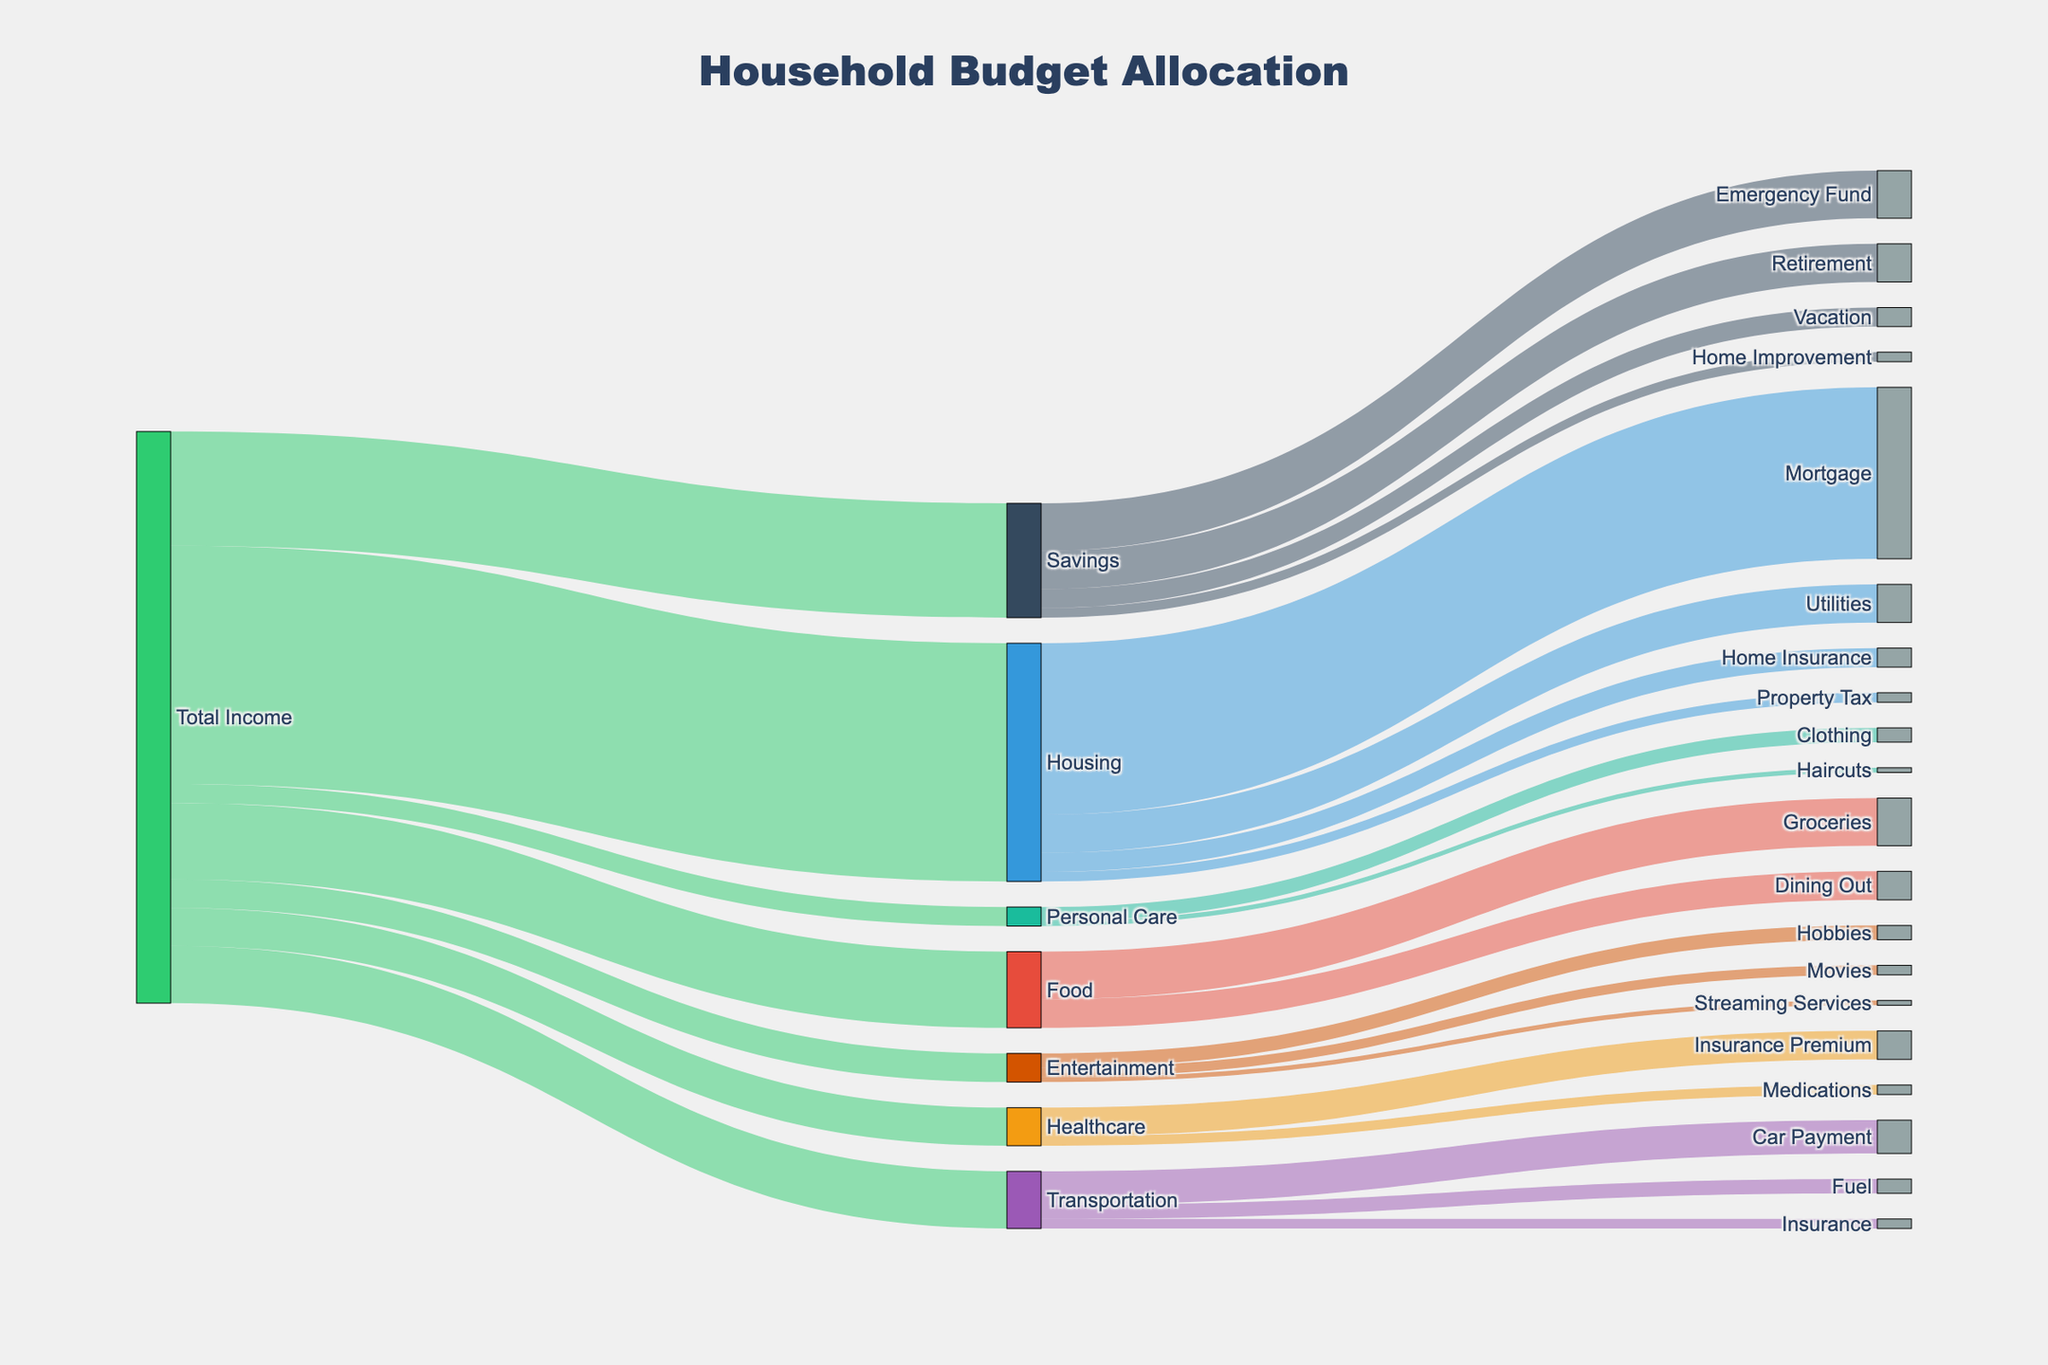What is the title of the diagram? The title of the diagram is located at the top and provides an immediate overview of the subject of the visualization.
Answer: Household Budget Allocation What is the total value allocated to savings from the total income? In the Sankey diagram, the flow from 'Total Income' to 'Savings' shows the amount allocated to savings.
Answer: 1200 How much is allocated to the Retirement savings goal? To find this, follow the flow from 'Savings' to 'Retirement'. The diagram indicates this value.
Answer: 400 Compare the amount allocated to Housing versus the amount allocated to Food. Which is higher? By observing the flows from 'Total Income' to 'Housing' and 'Food', we see that Housing is allocated 2500, while Food is allocated 800.
Answer: Housing What is the combined value allocated to Mortgage and Utilities under Housing? Under 'Housing', the flows to 'Mortgage' (1800) and 'Utilities' (400) together sum to 2200.
Answer: 2200 Which subcategory under Entertainment receives the highest allocation? By looking at the branches under 'Entertainment', compare the allocations: Streaming Services (50), Hobbies (150), and Movies (100). Hobbies receive the highest allocation.
Answer: Hobbies What percentage of the total income is allocated to Transportation? To find the percentage, divide the amount allocated to Transportation (600) by Total Income and multiply by 100: (600 / (2500 + 600 + 800 + 400 + 200 + 300 + 1200)) × 100. This equals approximately 8.33%.
Answer: 8.33% How much more is allocated to Emergency Fund compared to Vacation in the savings goal category? Subtract the allocation to Vacation (200) from Emergency Fund (500): 500 - 200.
Answer: 300 What are the two categories connected to Personal Care, and which receives the higher allocation? The connections from 'Personal Care' split into 'Haircuts' (50) and 'Clothing' (150). Clothing receives the higher allocation.
Answer: Haircuts and Clothing; Clothing Considering the entire budget, what is the total amount spent on Insurance? Summing all insurance-related flows: Home Insurance (200), Transportation Insurance (100), and Healthcare Insurance Premium (300) results in a total of 600.
Answer: 600 